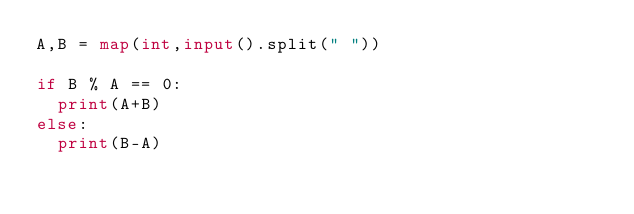<code> <loc_0><loc_0><loc_500><loc_500><_Python_>A,B = map(int,input().split(" "))

if B % A == 0:
  print(A+B)
else:
  print(B-A)</code> 